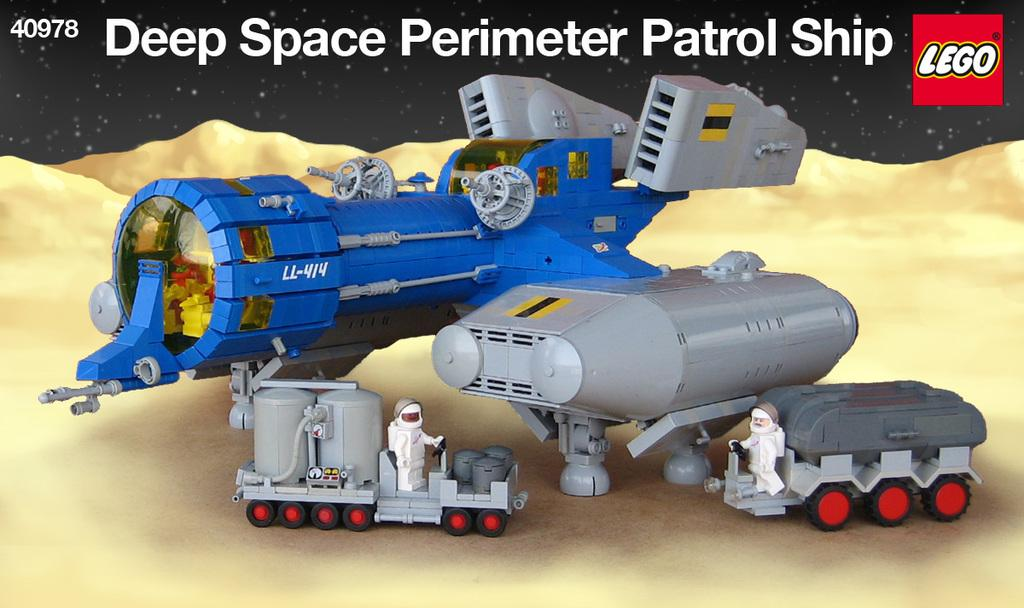What type of toy is in the image? There is a toy vehicle in the image. What colors are used for the toy vehicle? The toy vehicle is blue and gray in color. What other toys can be seen in the image? There are two white toys in front of the vehicle. What color is the background of the image? The background of the image is black in color. What type of hat is the toy vehicle wearing in the image? There is no hat present on the toy vehicle in the image. Is the toy vehicle attacking the white toys in the image? There is no indication of an attack in the image; the toys are simply placed in front of the vehicle. 